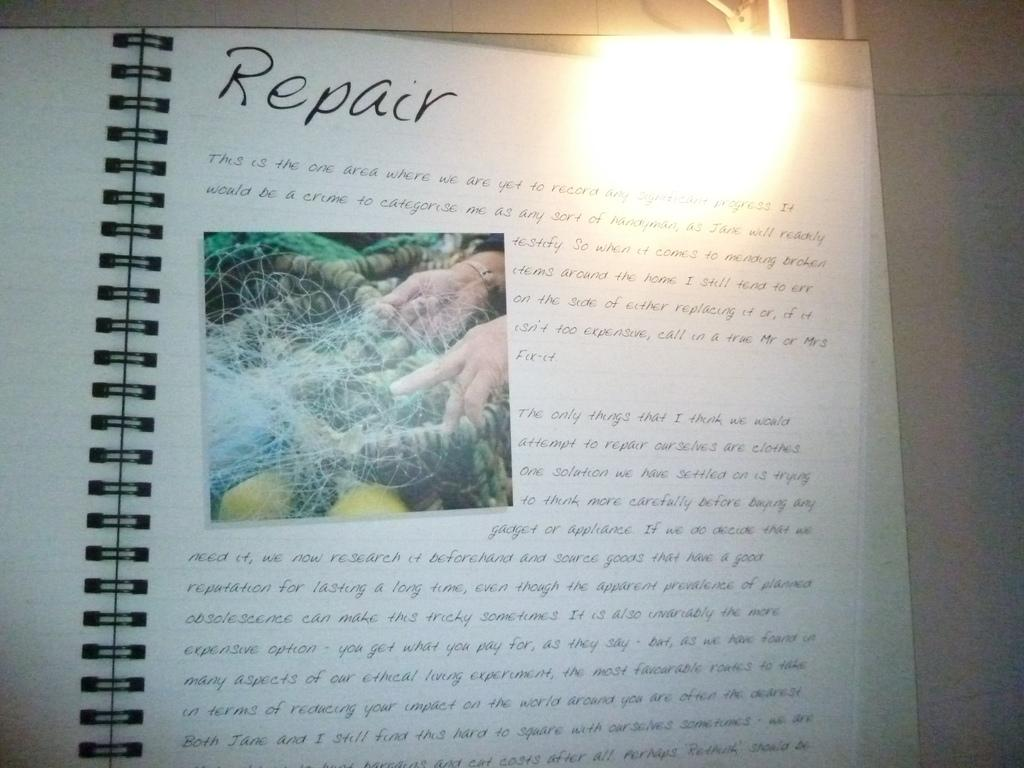What is the main object in the image? There is a book in the image. What type of content does the book contain? The book contains text and images. What is the color of the surface on the right side of the image? The surface on the right side of the image is white. Where is the light source coming from in the image? The light source is at the top of the book in the image. What grade is the student studying in the image? There is no student or grade present in the image; it only features a book with text and images. Is the moon visible in the image? The moon is not visible in the image; it only features a book with text and images on a white surface. 